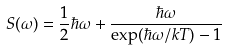Convert formula to latex. <formula><loc_0><loc_0><loc_500><loc_500>S ( \omega ) = \frac { 1 } { 2 } \hbar { \omega } + \frac { \hbar { \omega } } { \exp ( \hbar { \omega } / k T ) - 1 }</formula> 